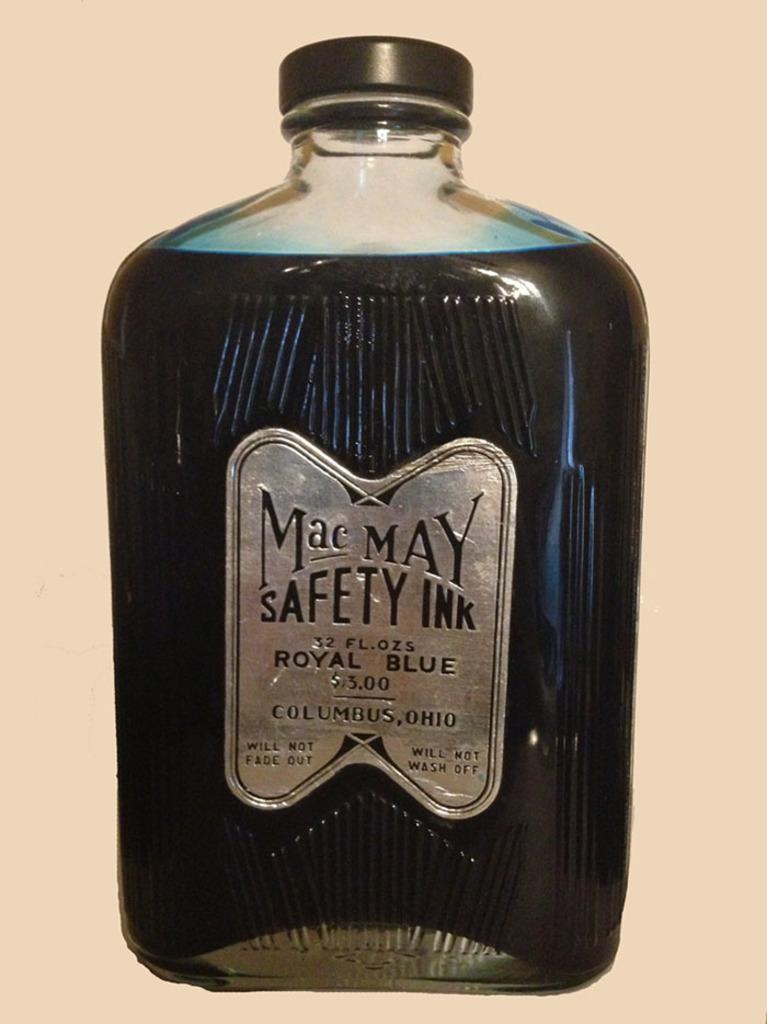Could you give a brief overview of what you see in this image? Here we can see a bottle present with Mac May safety written on it 